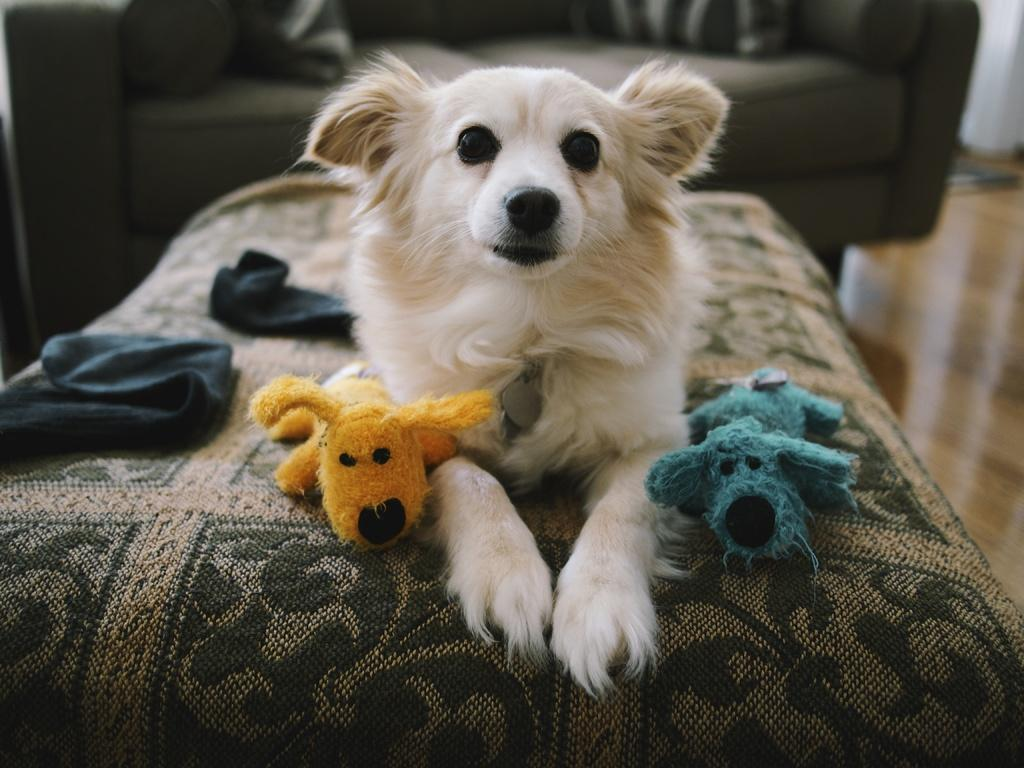What type of animal can be seen in the image? There is a dog in the image. What other objects are present with the dog? There are soft toys and napkins in the image. Where are these objects located? The objects are on a couch. What can be seen in the background of the image? There is a sofa set in the background of the image. What type of mask is the dog wearing in the image? There is no mask present in the image; the dog is not wearing any mask. 